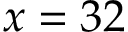Convert formula to latex. <formula><loc_0><loc_0><loc_500><loc_500>x = 3 2</formula> 